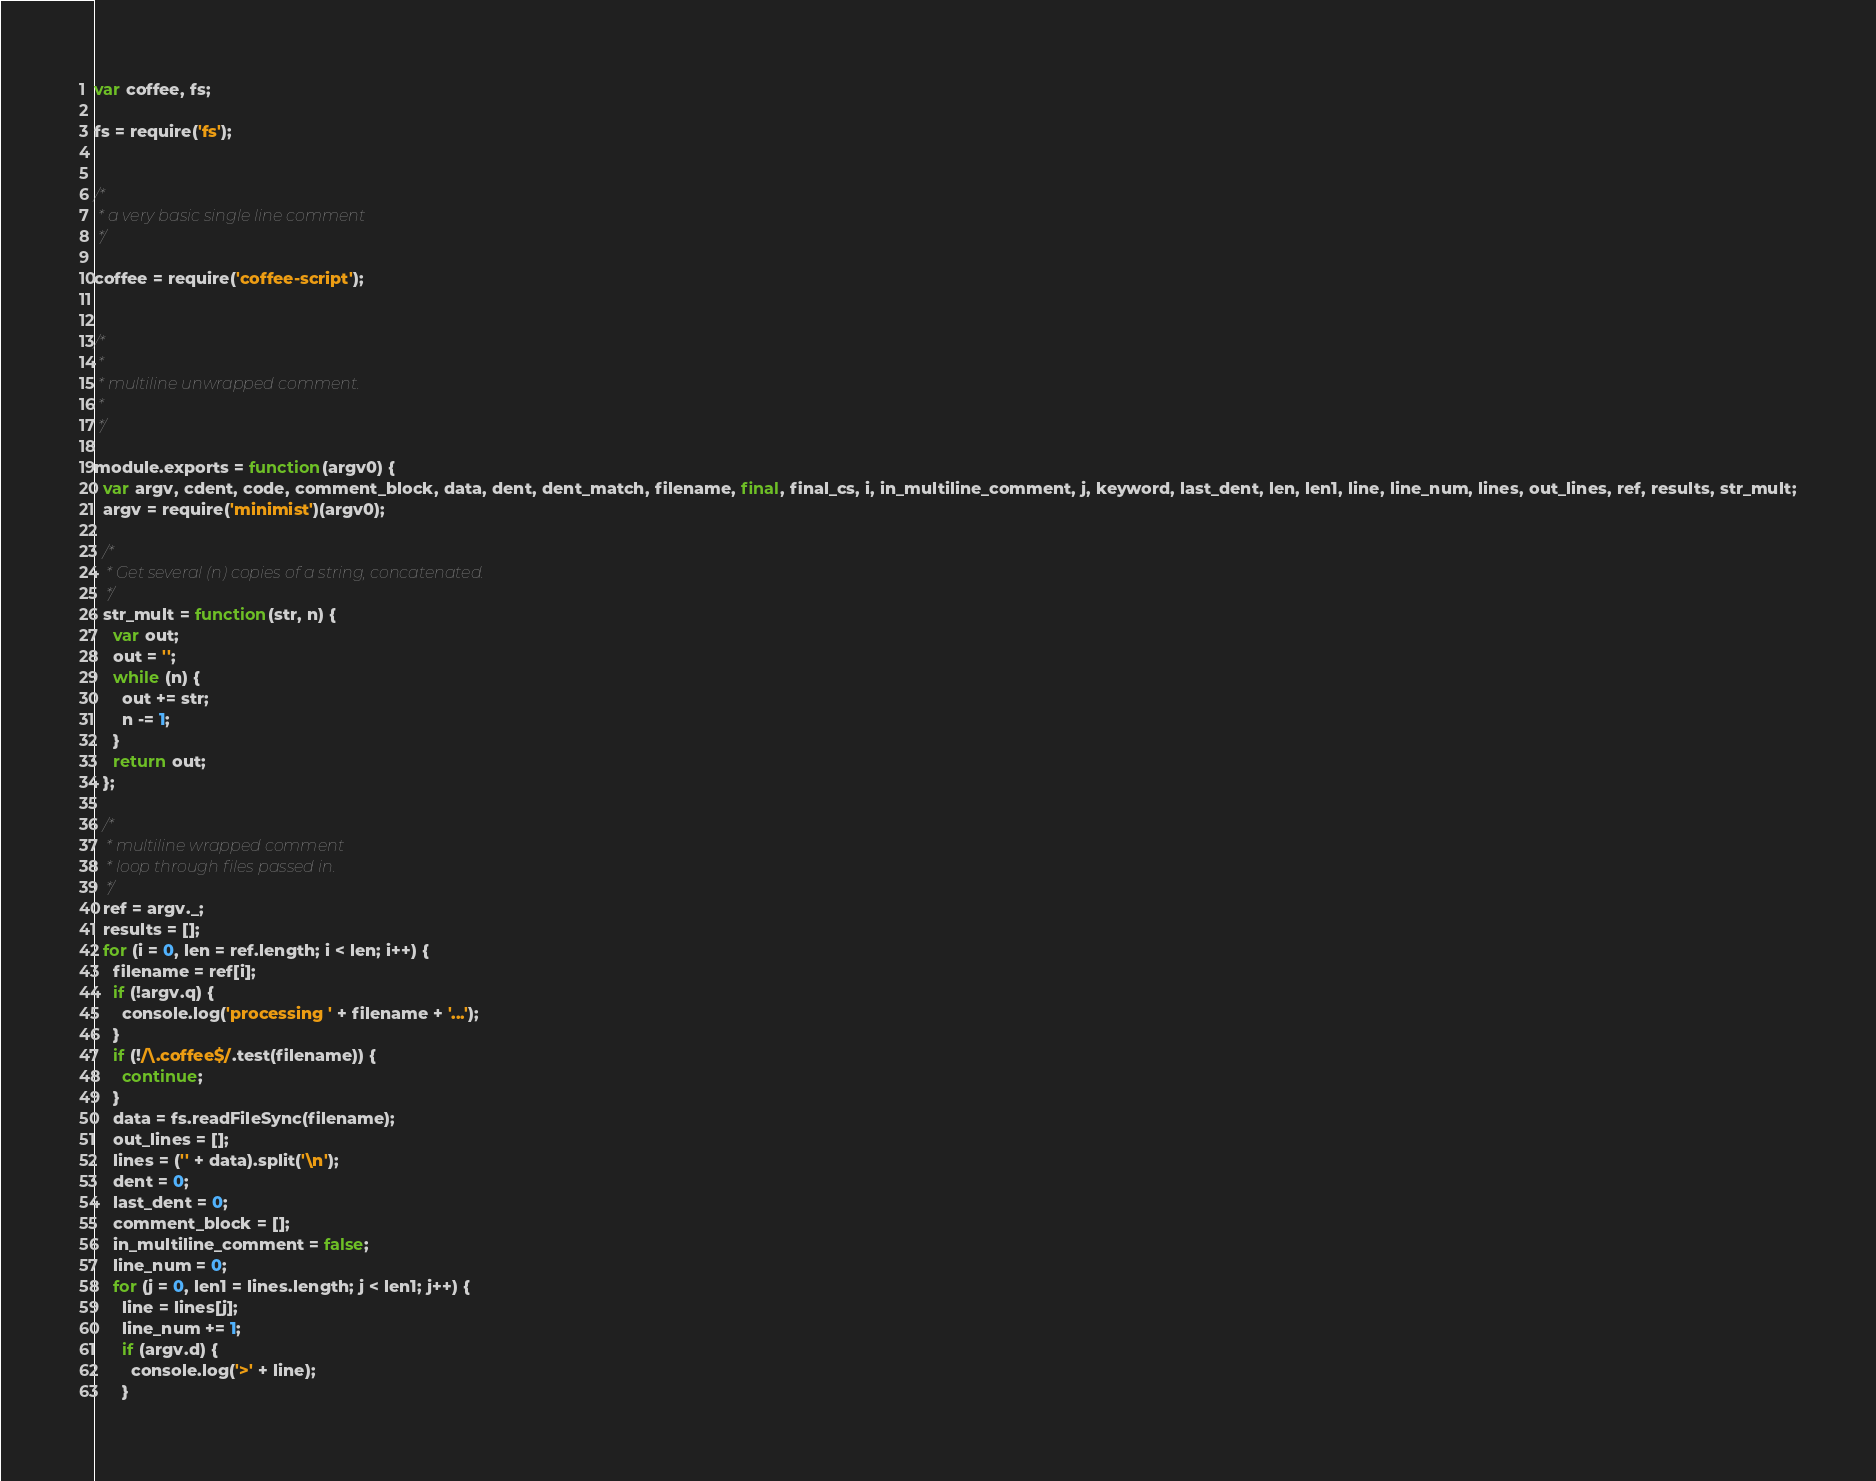Convert code to text. <code><loc_0><loc_0><loc_500><loc_500><_JavaScript_>var coffee, fs;

fs = require('fs');


/*
 * a very basic single line comment
 */

coffee = require('coffee-script');


/*
 *
 * multiline unwrapped comment.
 *
 */

module.exports = function(argv0) {
  var argv, cdent, code, comment_block, data, dent, dent_match, filename, final, final_cs, i, in_multiline_comment, j, keyword, last_dent, len, len1, line, line_num, lines, out_lines, ref, results, str_mult;
  argv = require('minimist')(argv0);

  /*
   * Get several (n) copies of a string, concatenated.
   */
  str_mult = function(str, n) {
    var out;
    out = '';
    while (n) {
      out += str;
      n -= 1;
    }
    return out;
  };

  /*
   * multiline wrapped comment
   * loop through files passed in.
   */
  ref = argv._;
  results = [];
  for (i = 0, len = ref.length; i < len; i++) {
    filename = ref[i];
    if (!argv.q) {
      console.log('processing ' + filename + '...');
    }
    if (!/\.coffee$/.test(filename)) {
      continue;
    }
    data = fs.readFileSync(filename);
    out_lines = [];
    lines = ('' + data).split('\n');
    dent = 0;
    last_dent = 0;
    comment_block = [];
    in_multiline_comment = false;
    line_num = 0;
    for (j = 0, len1 = lines.length; j < len1; j++) {
      line = lines[j];
      line_num += 1;
      if (argv.d) {
        console.log('>' + line);
      }</code> 